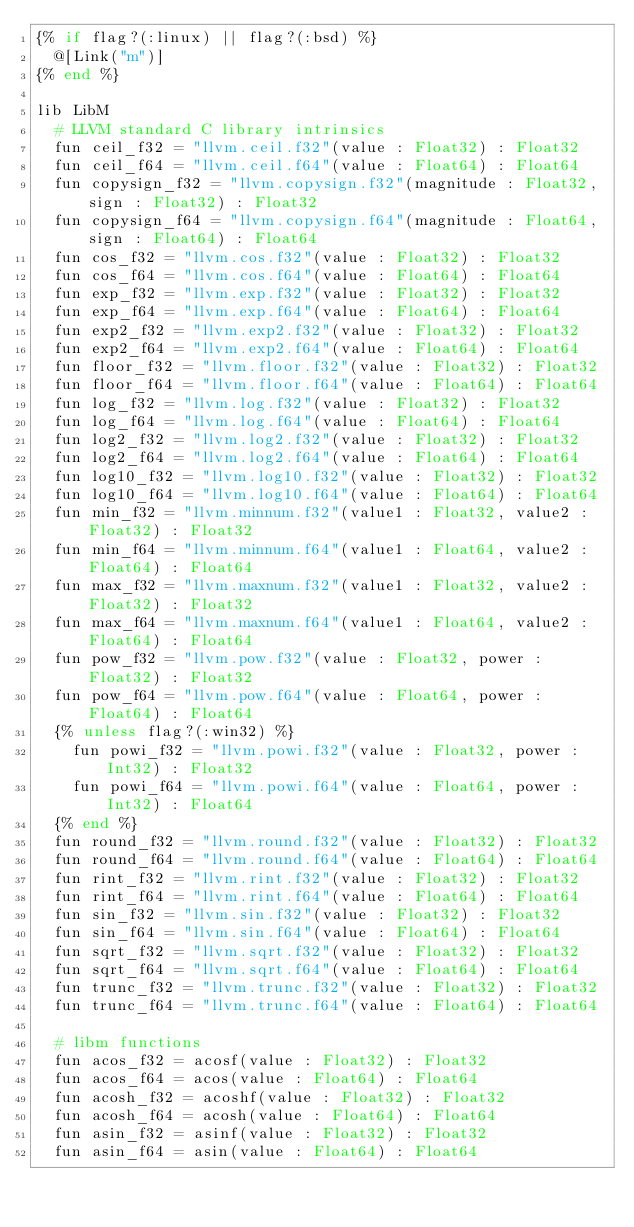<code> <loc_0><loc_0><loc_500><loc_500><_Crystal_>{% if flag?(:linux) || flag?(:bsd) %}
  @[Link("m")]
{% end %}

lib LibM
  # LLVM standard C library intrinsics
  fun ceil_f32 = "llvm.ceil.f32"(value : Float32) : Float32
  fun ceil_f64 = "llvm.ceil.f64"(value : Float64) : Float64
  fun copysign_f32 = "llvm.copysign.f32"(magnitude : Float32, sign : Float32) : Float32
  fun copysign_f64 = "llvm.copysign.f64"(magnitude : Float64, sign : Float64) : Float64
  fun cos_f32 = "llvm.cos.f32"(value : Float32) : Float32
  fun cos_f64 = "llvm.cos.f64"(value : Float64) : Float64
  fun exp_f32 = "llvm.exp.f32"(value : Float32) : Float32
  fun exp_f64 = "llvm.exp.f64"(value : Float64) : Float64
  fun exp2_f32 = "llvm.exp2.f32"(value : Float32) : Float32
  fun exp2_f64 = "llvm.exp2.f64"(value : Float64) : Float64
  fun floor_f32 = "llvm.floor.f32"(value : Float32) : Float32
  fun floor_f64 = "llvm.floor.f64"(value : Float64) : Float64
  fun log_f32 = "llvm.log.f32"(value : Float32) : Float32
  fun log_f64 = "llvm.log.f64"(value : Float64) : Float64
  fun log2_f32 = "llvm.log2.f32"(value : Float32) : Float32
  fun log2_f64 = "llvm.log2.f64"(value : Float64) : Float64
  fun log10_f32 = "llvm.log10.f32"(value : Float32) : Float32
  fun log10_f64 = "llvm.log10.f64"(value : Float64) : Float64
  fun min_f32 = "llvm.minnum.f32"(value1 : Float32, value2 : Float32) : Float32
  fun min_f64 = "llvm.minnum.f64"(value1 : Float64, value2 : Float64) : Float64
  fun max_f32 = "llvm.maxnum.f32"(value1 : Float32, value2 : Float32) : Float32
  fun max_f64 = "llvm.maxnum.f64"(value1 : Float64, value2 : Float64) : Float64
  fun pow_f32 = "llvm.pow.f32"(value : Float32, power : Float32) : Float32
  fun pow_f64 = "llvm.pow.f64"(value : Float64, power : Float64) : Float64
  {% unless flag?(:win32) %}
    fun powi_f32 = "llvm.powi.f32"(value : Float32, power : Int32) : Float32
    fun powi_f64 = "llvm.powi.f64"(value : Float64, power : Int32) : Float64
  {% end %}
  fun round_f32 = "llvm.round.f32"(value : Float32) : Float32
  fun round_f64 = "llvm.round.f64"(value : Float64) : Float64
  fun rint_f32 = "llvm.rint.f32"(value : Float32) : Float32
  fun rint_f64 = "llvm.rint.f64"(value : Float64) : Float64
  fun sin_f32 = "llvm.sin.f32"(value : Float32) : Float32
  fun sin_f64 = "llvm.sin.f64"(value : Float64) : Float64
  fun sqrt_f32 = "llvm.sqrt.f32"(value : Float32) : Float32
  fun sqrt_f64 = "llvm.sqrt.f64"(value : Float64) : Float64
  fun trunc_f32 = "llvm.trunc.f32"(value : Float32) : Float32
  fun trunc_f64 = "llvm.trunc.f64"(value : Float64) : Float64

  # libm functions
  fun acos_f32 = acosf(value : Float32) : Float32
  fun acos_f64 = acos(value : Float64) : Float64
  fun acosh_f32 = acoshf(value : Float32) : Float32
  fun acosh_f64 = acosh(value : Float64) : Float64
  fun asin_f32 = asinf(value : Float32) : Float32
  fun asin_f64 = asin(value : Float64) : Float64</code> 